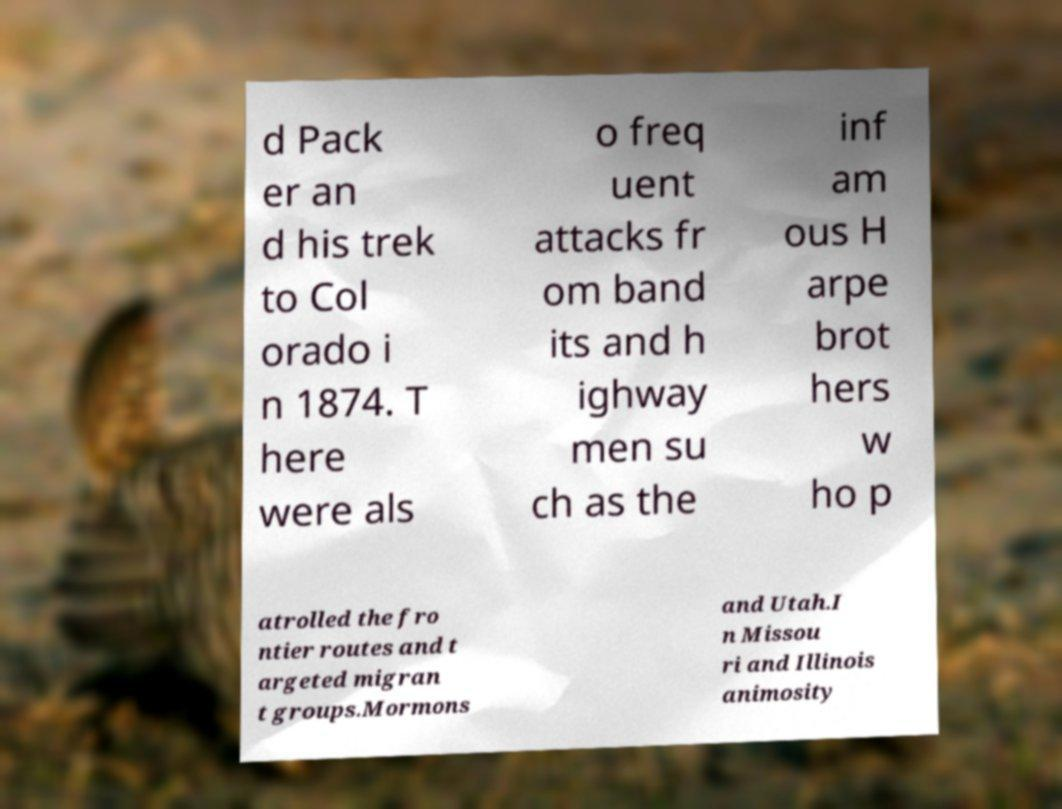There's text embedded in this image that I need extracted. Can you transcribe it verbatim? d Pack er an d his trek to Col orado i n 1874. T here were als o freq uent attacks fr om band its and h ighway men su ch as the inf am ous H arpe brot hers w ho p atrolled the fro ntier routes and t argeted migran t groups.Mormons and Utah.I n Missou ri and Illinois animosity 